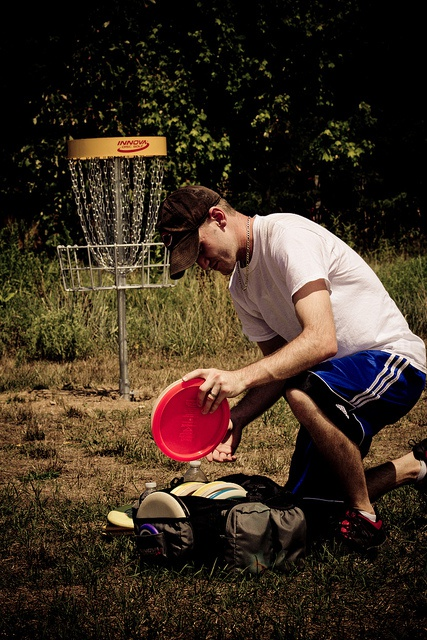Describe the objects in this image and their specific colors. I can see people in black, lightgray, brown, and tan tones, backpack in black and gray tones, handbag in black and gray tones, frisbee in black, brown, maroon, and salmon tones, and frisbee in black, gray, and tan tones in this image. 